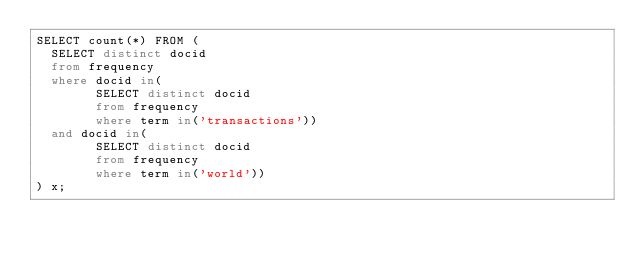<code> <loc_0><loc_0><loc_500><loc_500><_SQL_>SELECT count(*) FROM (
  SELECT distinct docid
  from frequency
  where docid in(
        SELECT distinct docid
        from frequency
        where term in('transactions'))
  and docid in(
        SELECT distinct docid
        from frequency
        where term in('world'))
) x;
</code> 